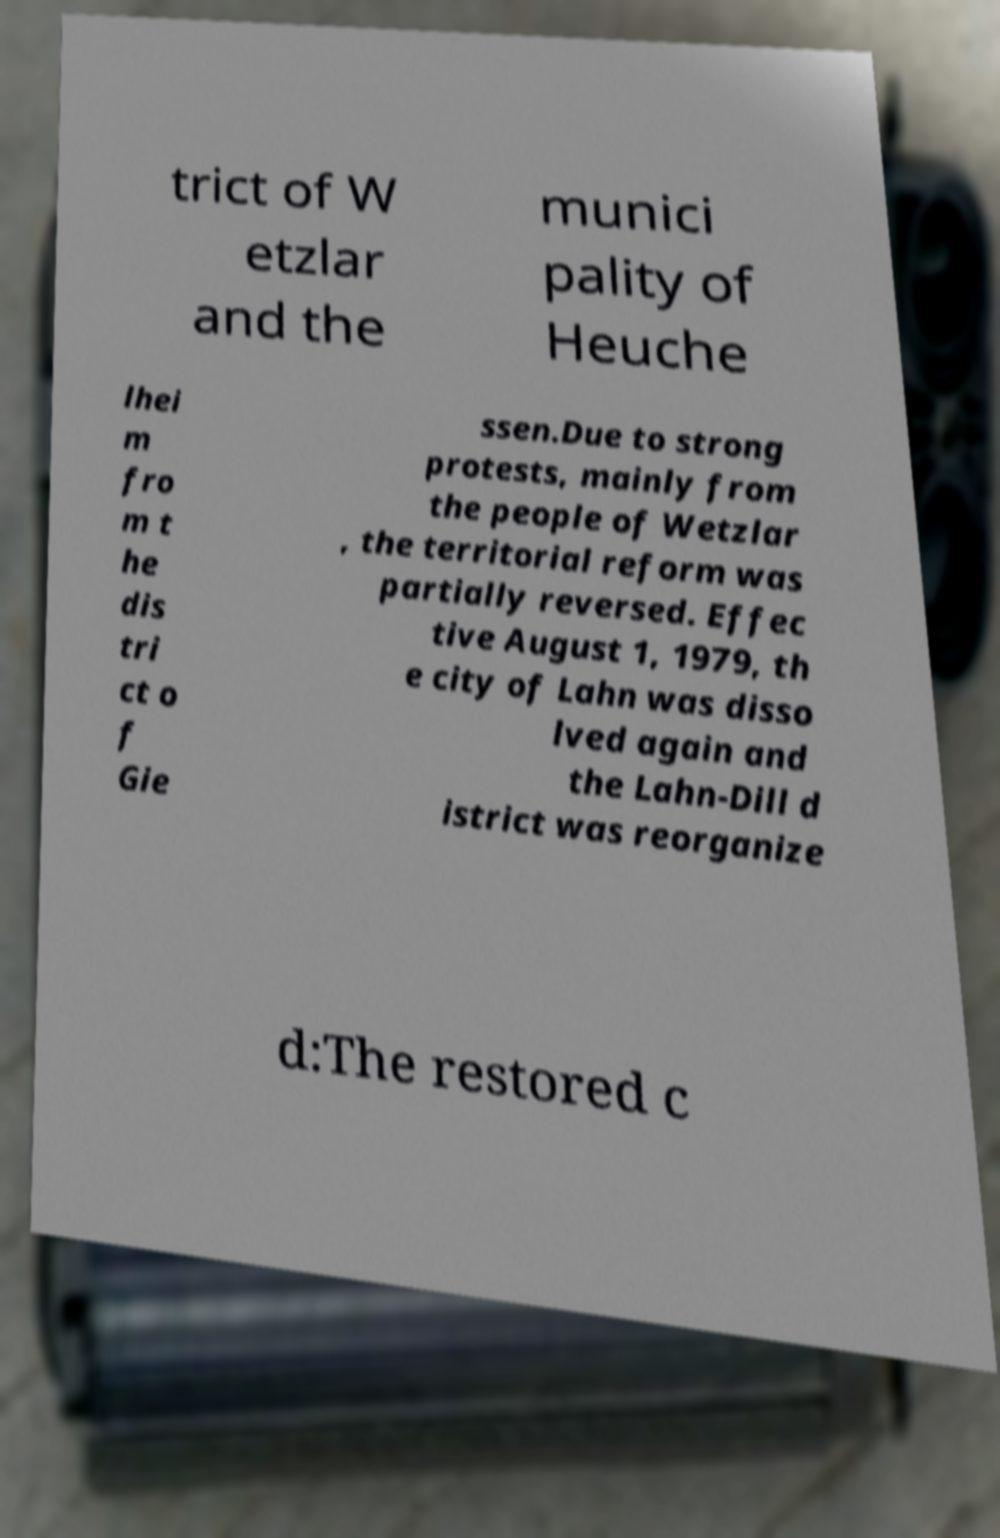I need the written content from this picture converted into text. Can you do that? trict of W etzlar and the munici pality of Heuche lhei m fro m t he dis tri ct o f Gie ssen.Due to strong protests, mainly from the people of Wetzlar , the territorial reform was partially reversed. Effec tive August 1, 1979, th e city of Lahn was disso lved again and the Lahn-Dill d istrict was reorganize d:The restored c 